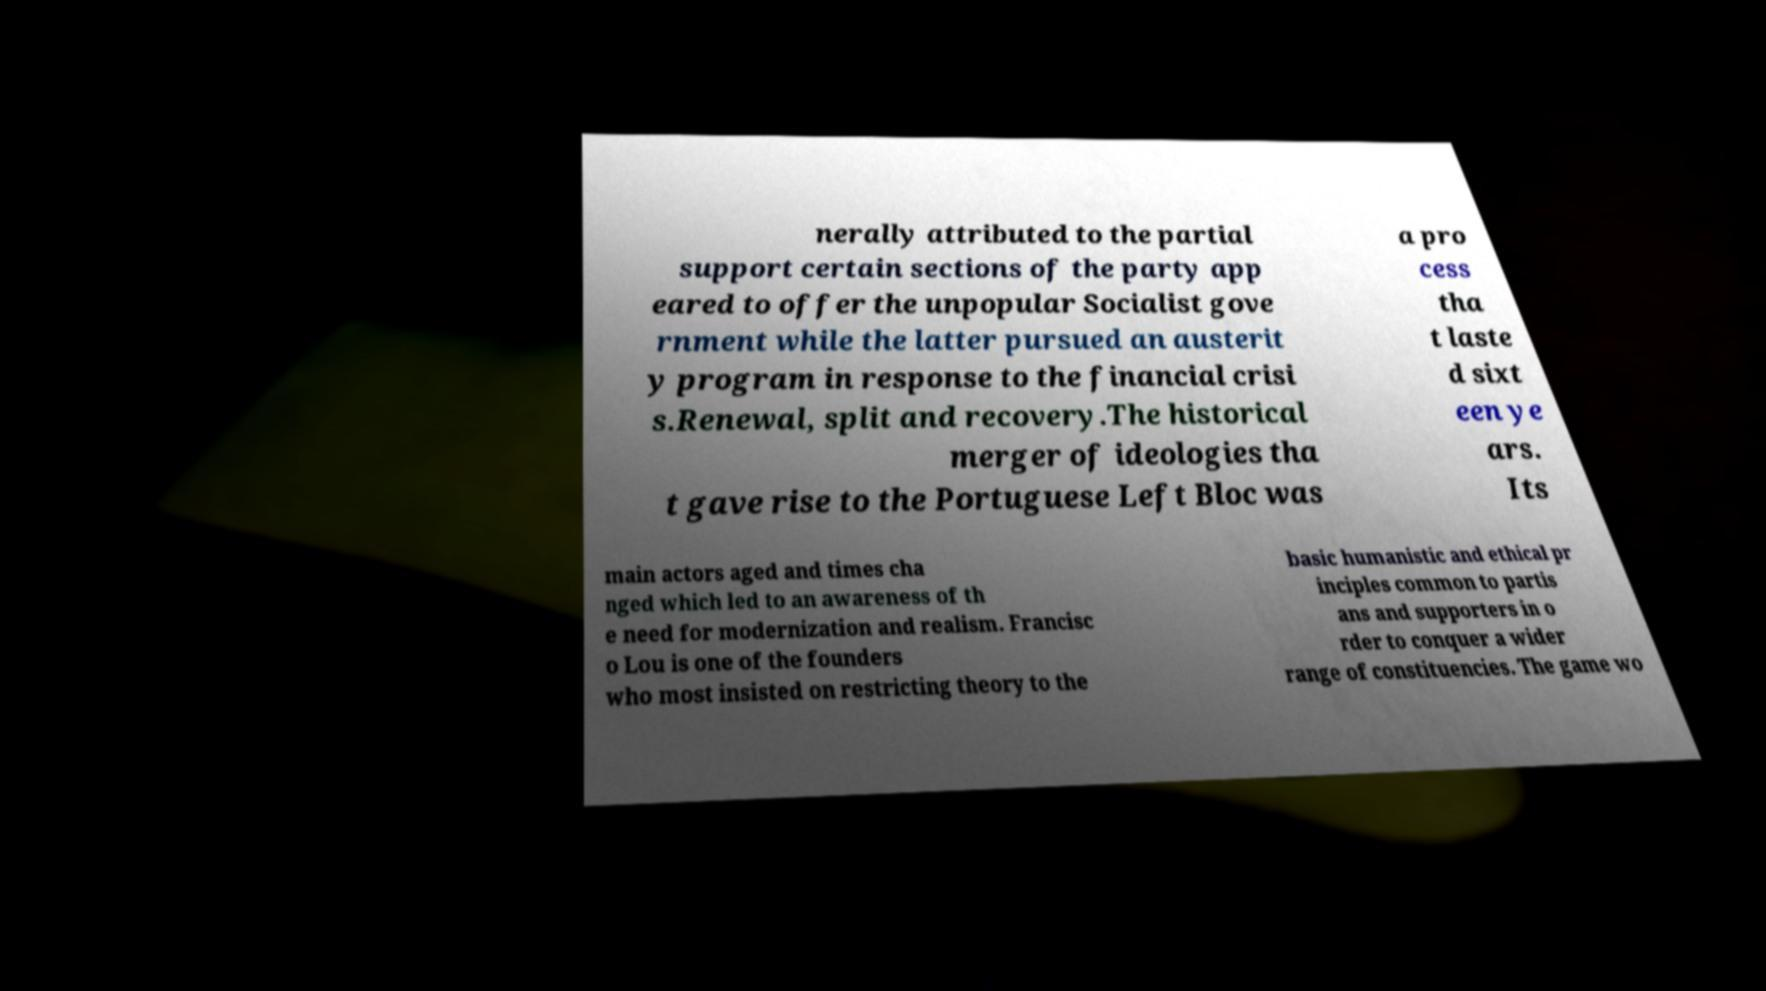There's text embedded in this image that I need extracted. Can you transcribe it verbatim? nerally attributed to the partial support certain sections of the party app eared to offer the unpopular Socialist gove rnment while the latter pursued an austerit y program in response to the financial crisi s.Renewal, split and recovery.The historical merger of ideologies tha t gave rise to the Portuguese Left Bloc was a pro cess tha t laste d sixt een ye ars. Its main actors aged and times cha nged which led to an awareness of th e need for modernization and realism. Francisc o Lou is one of the founders who most insisted on restricting theory to the basic humanistic and ethical pr inciples common to partis ans and supporters in o rder to conquer a wider range of constituencies. The game wo 